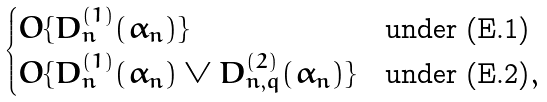Convert formula to latex. <formula><loc_0><loc_0><loc_500><loc_500>\begin{cases} O \{ D _ { n } ^ { ( 1 ) } ( \alpha _ { n } ) \} & \text {under (E.1)} \\ O \{ D _ { n } ^ { ( 1 ) } ( \alpha _ { n } ) \vee D _ { n , q } ^ { ( 2 ) } ( \alpha _ { n } ) \} & \text {under (E.2)} , \end{cases}</formula> 